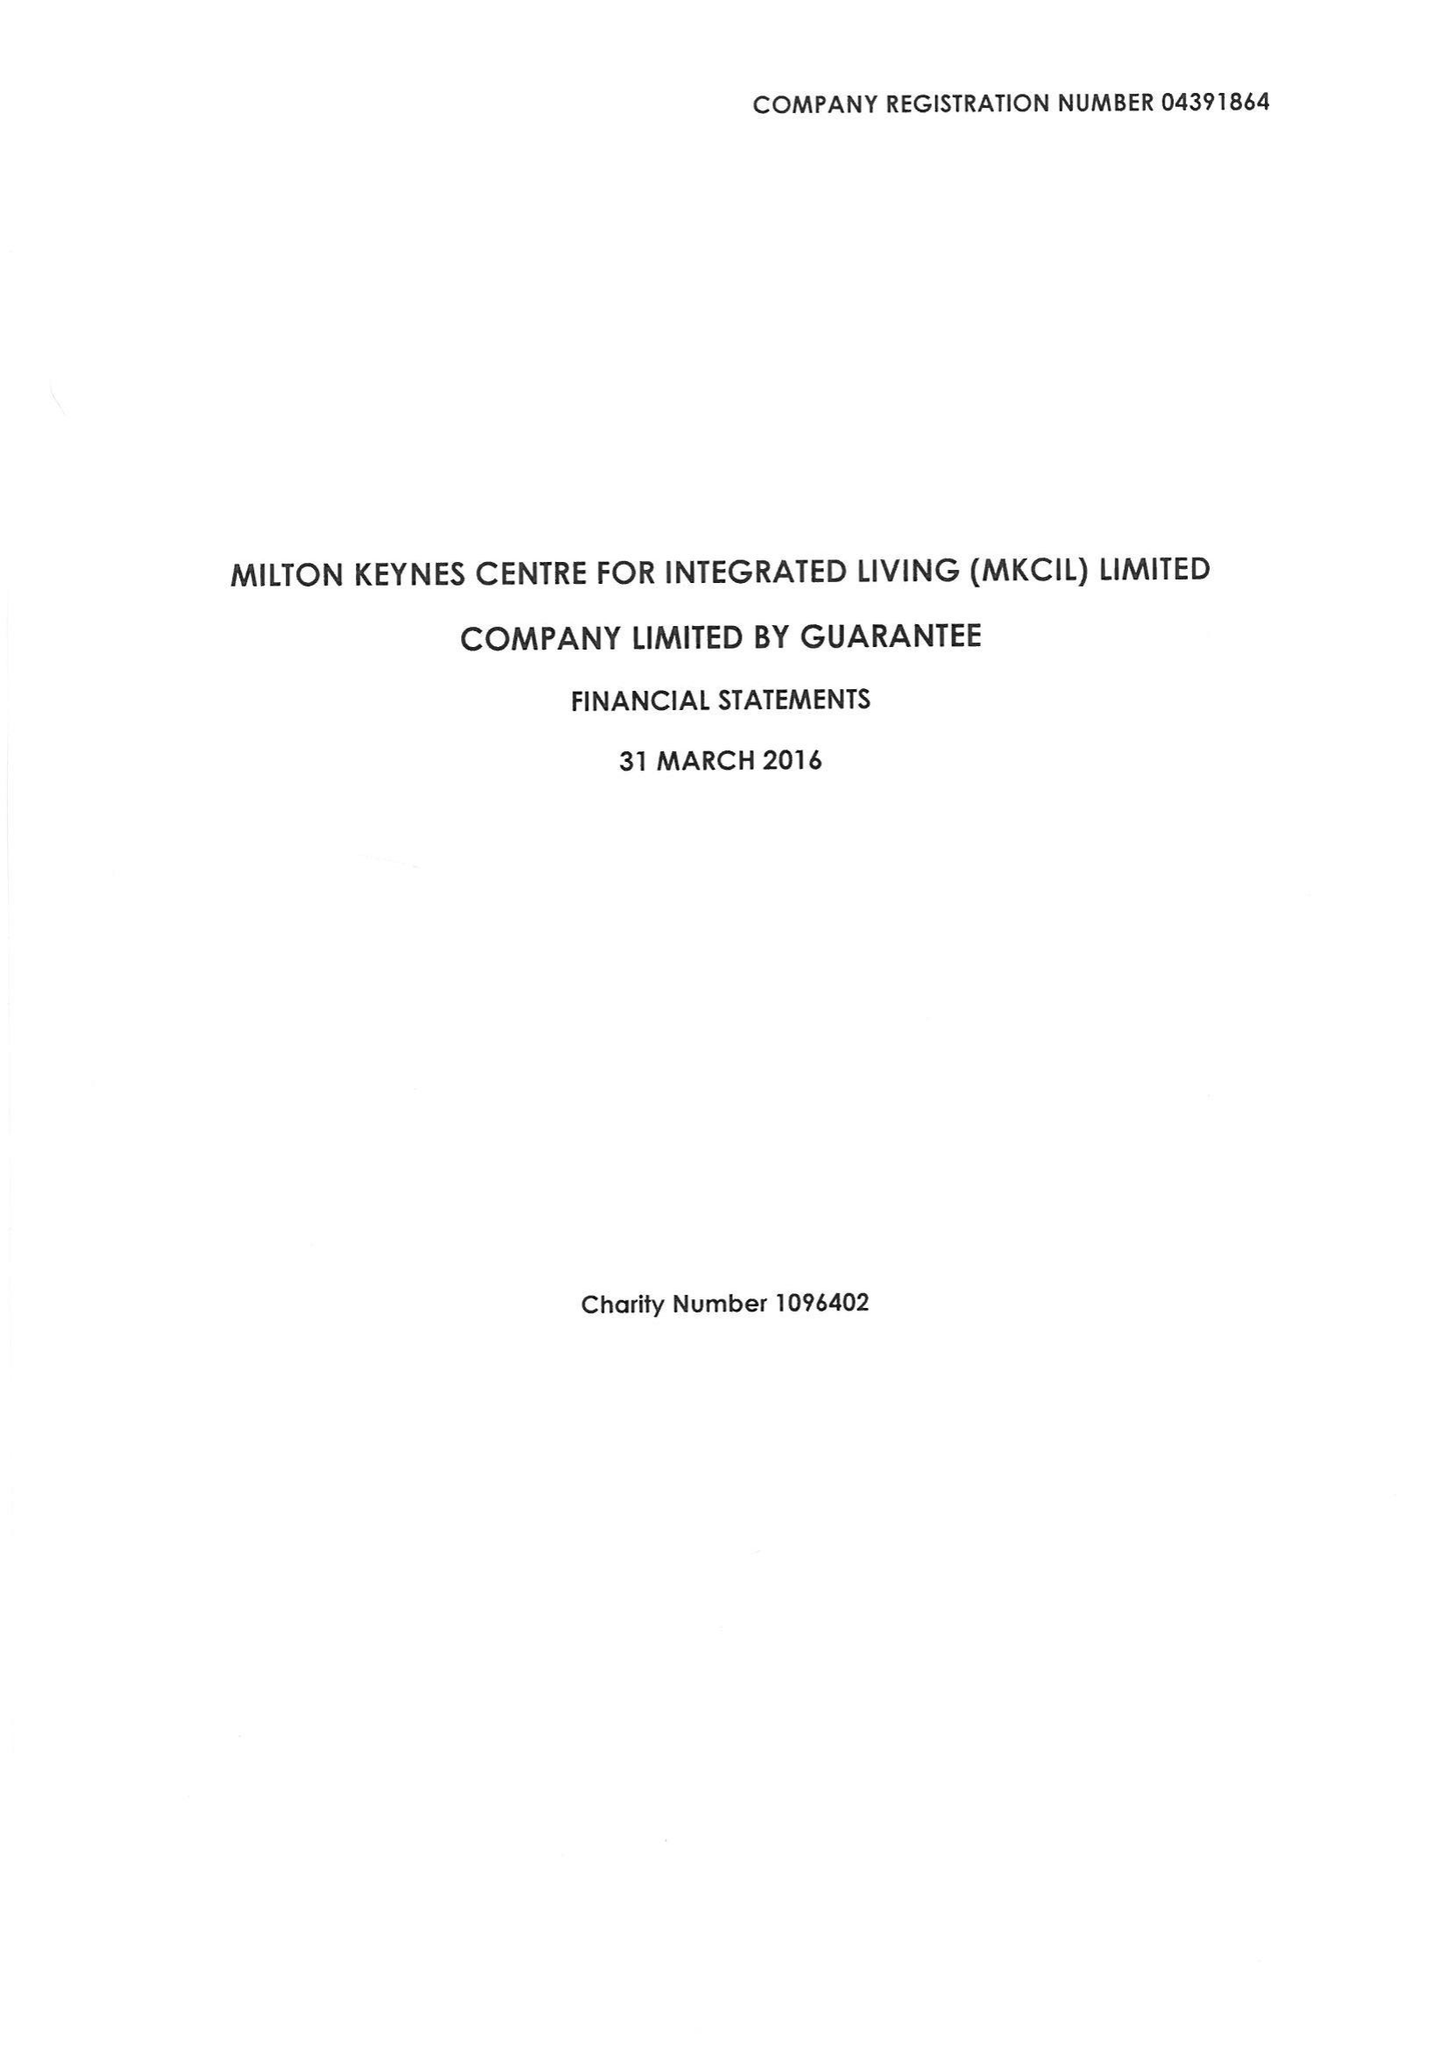What is the value for the spending_annually_in_british_pounds?
Answer the question using a single word or phrase. 387723.00 